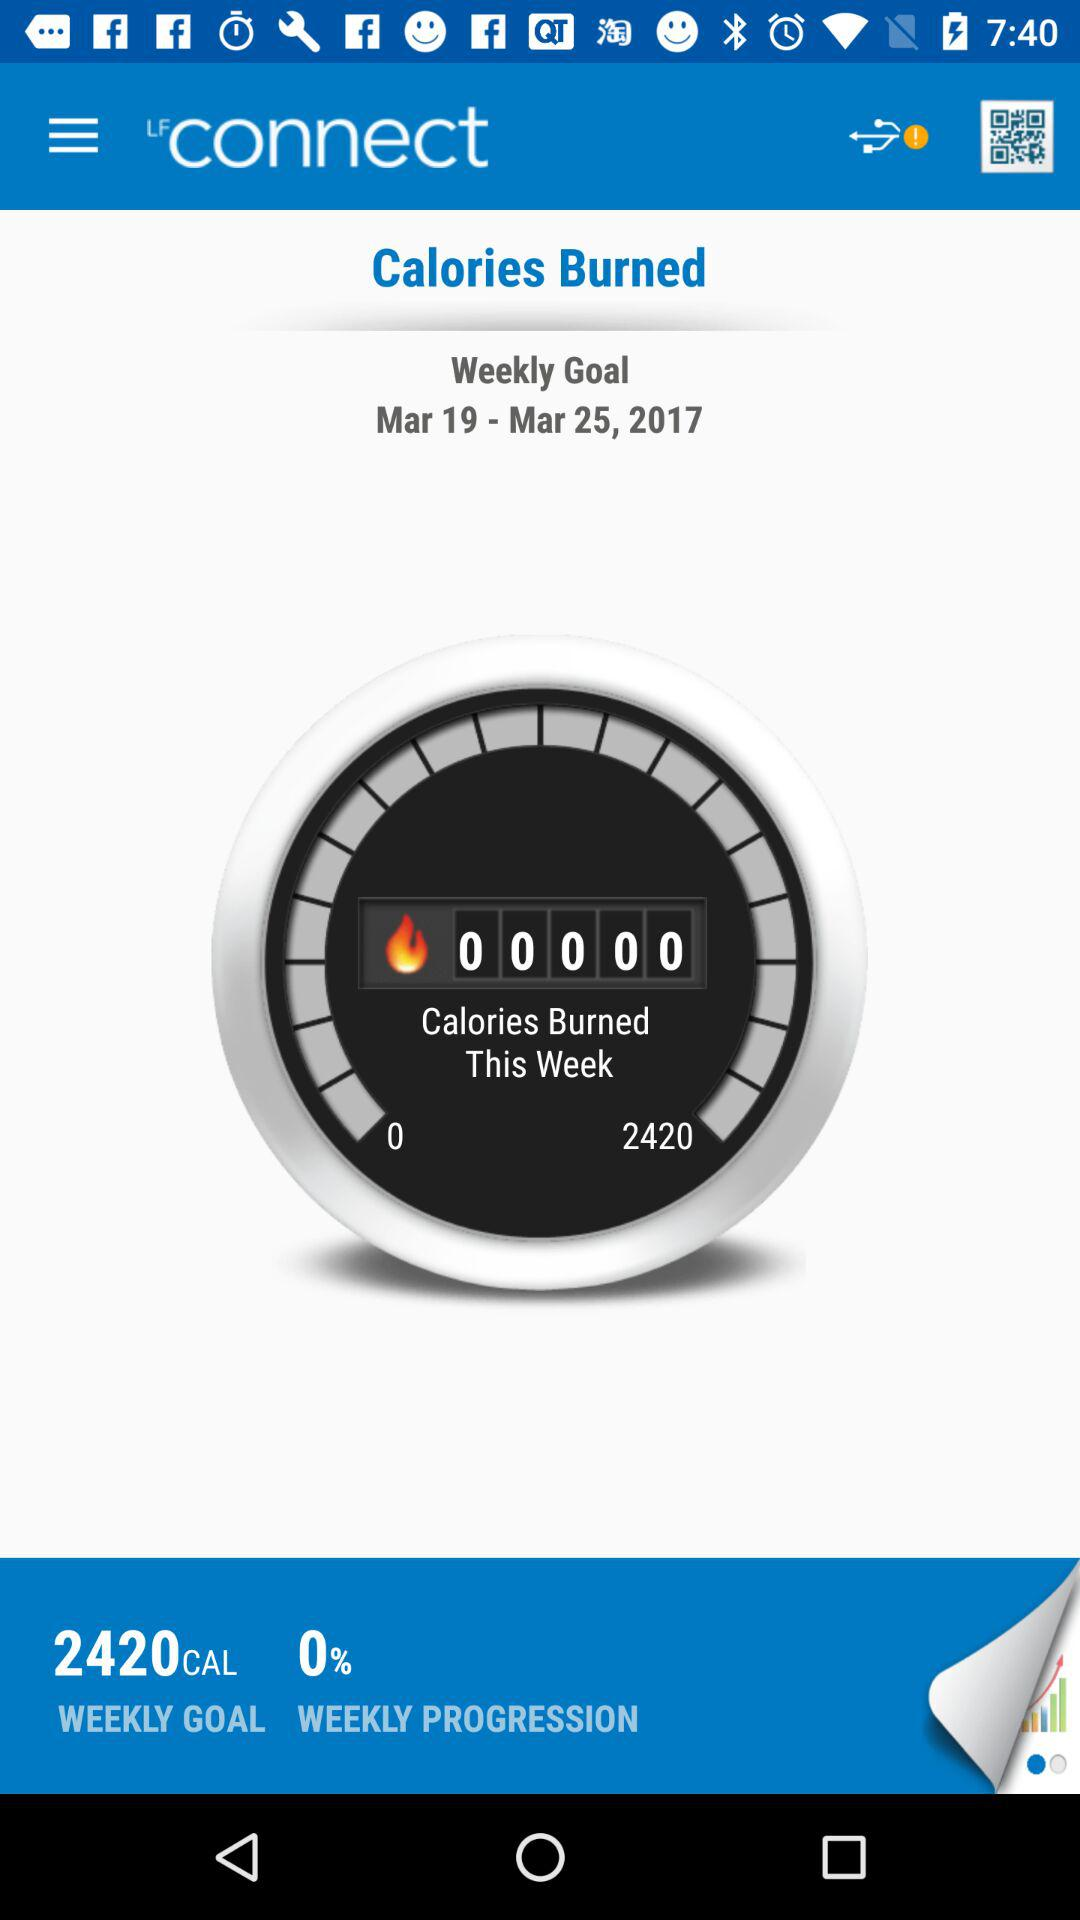What percentage of my weekly goal have I burned?
Answer the question using a single word or phrase. 0% 